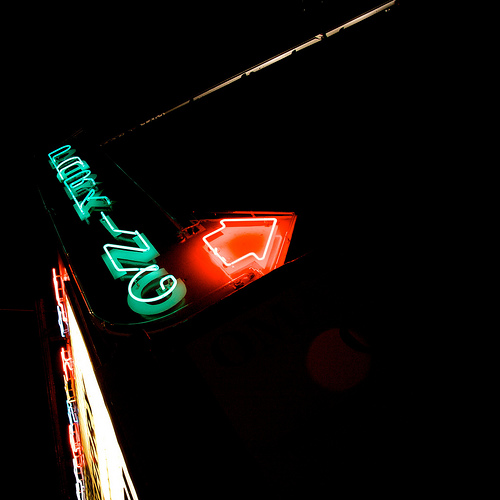<image>
Is the arrow on the wall? Yes. Looking at the image, I can see the arrow is positioned on top of the wall, with the wall providing support. Is there a parking sign next to the arrow? Yes. The parking sign is positioned adjacent to the arrow, located nearby in the same general area. 